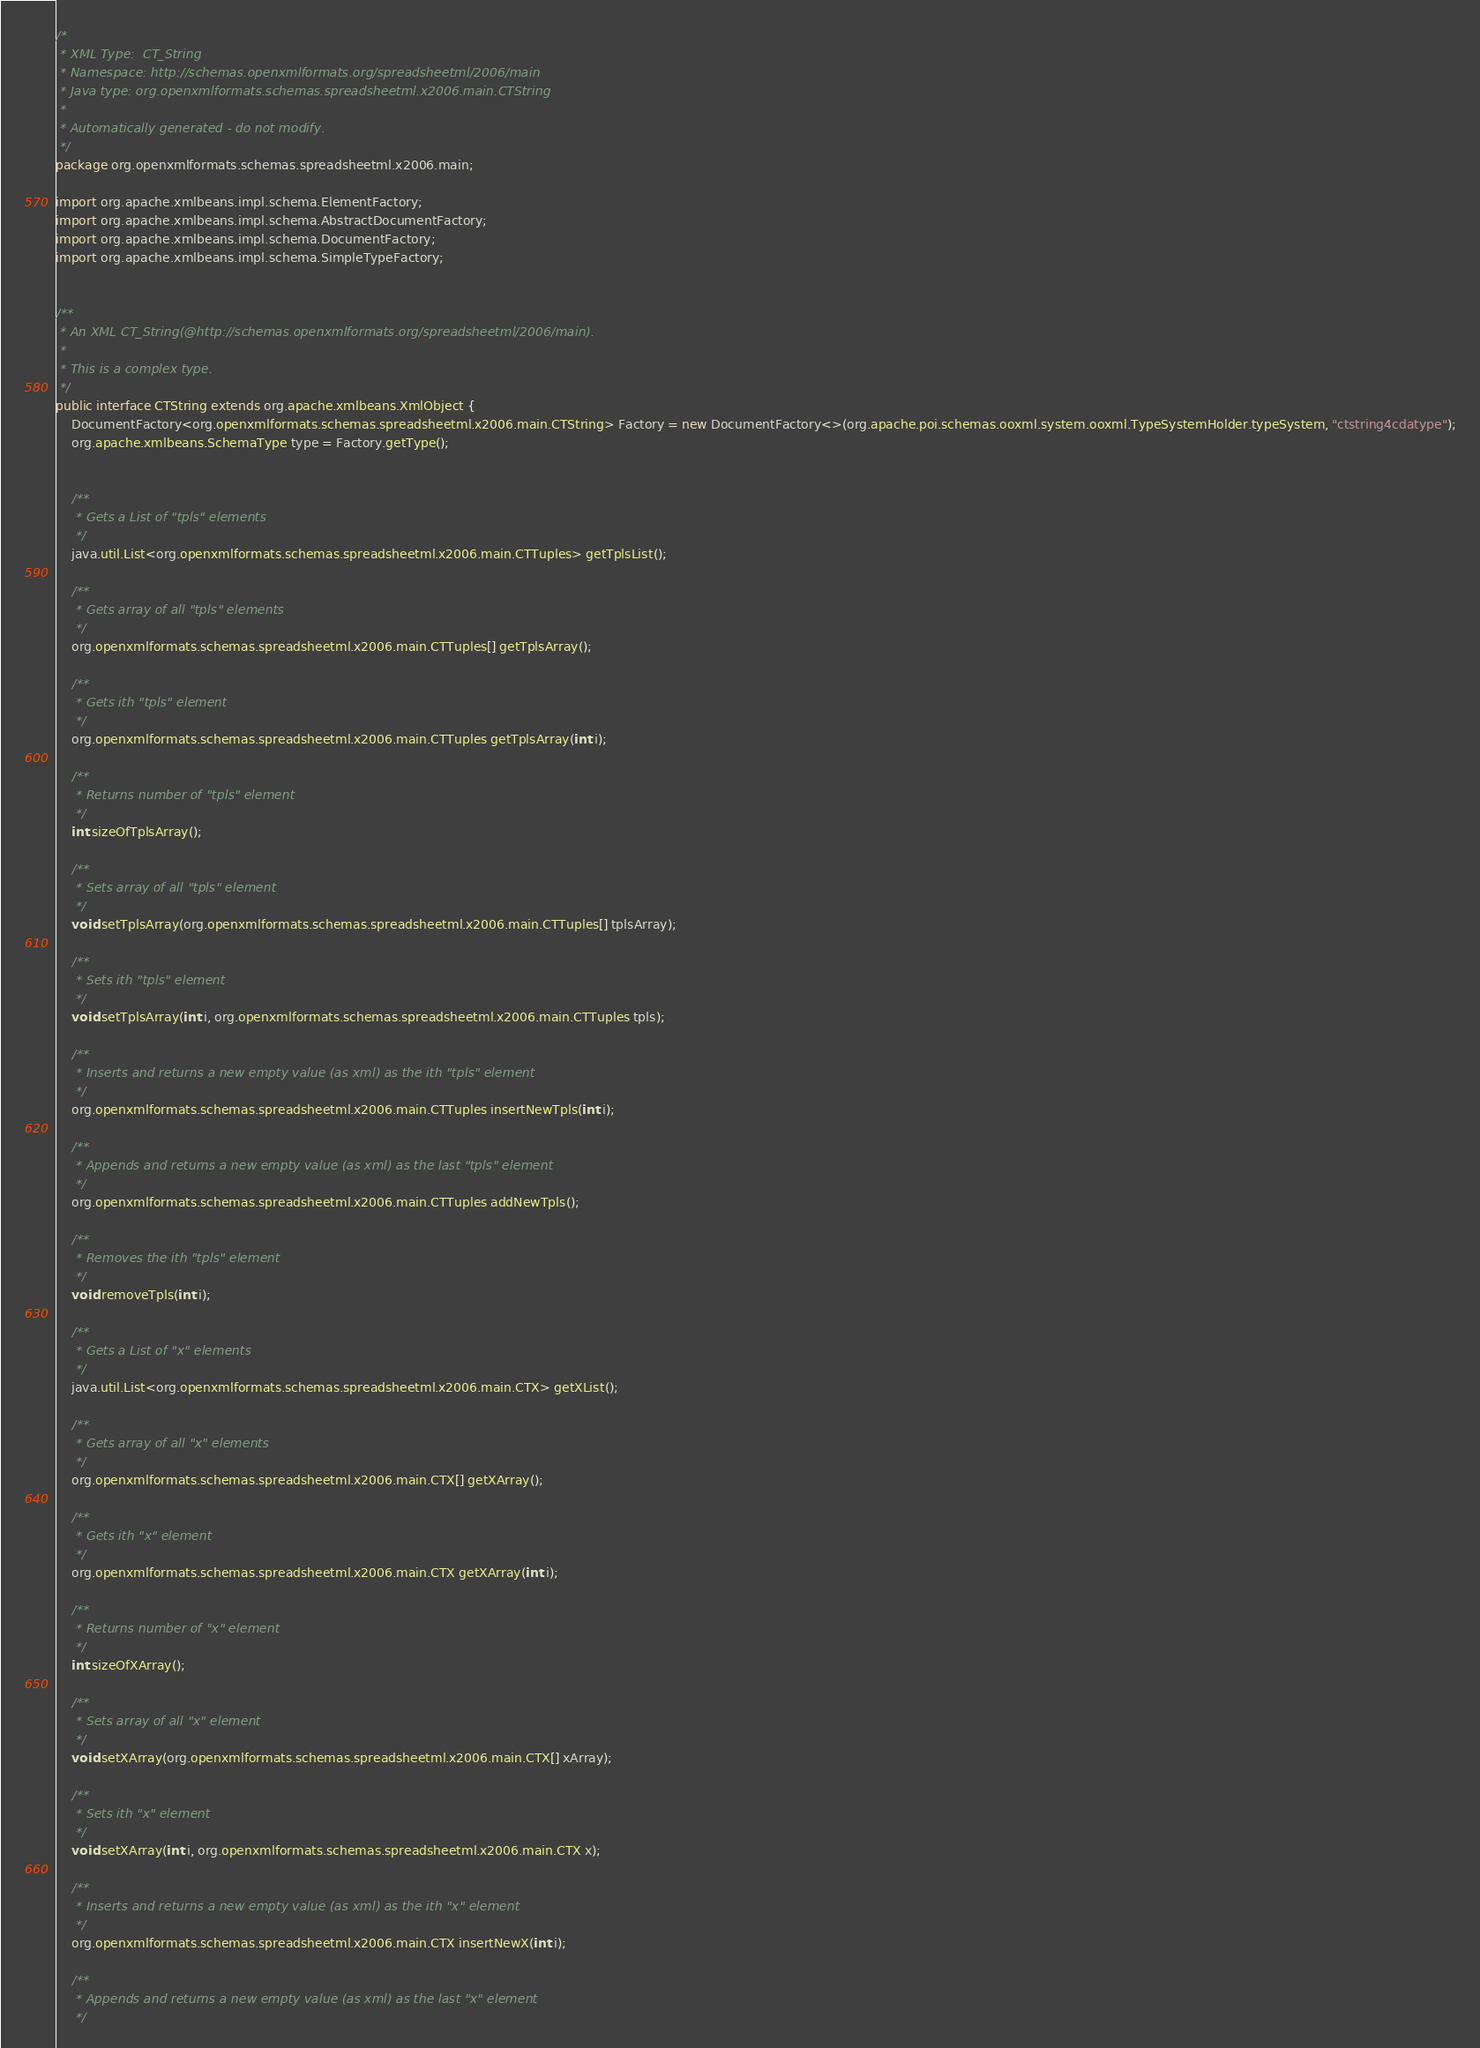Convert code to text. <code><loc_0><loc_0><loc_500><loc_500><_Java_>/*
 * XML Type:  CT_String
 * Namespace: http://schemas.openxmlformats.org/spreadsheetml/2006/main
 * Java type: org.openxmlformats.schemas.spreadsheetml.x2006.main.CTString
 *
 * Automatically generated - do not modify.
 */
package org.openxmlformats.schemas.spreadsheetml.x2006.main;

import org.apache.xmlbeans.impl.schema.ElementFactory;
import org.apache.xmlbeans.impl.schema.AbstractDocumentFactory;
import org.apache.xmlbeans.impl.schema.DocumentFactory;
import org.apache.xmlbeans.impl.schema.SimpleTypeFactory;


/**
 * An XML CT_String(@http://schemas.openxmlformats.org/spreadsheetml/2006/main).
 *
 * This is a complex type.
 */
public interface CTString extends org.apache.xmlbeans.XmlObject {
    DocumentFactory<org.openxmlformats.schemas.spreadsheetml.x2006.main.CTString> Factory = new DocumentFactory<>(org.apache.poi.schemas.ooxml.system.ooxml.TypeSystemHolder.typeSystem, "ctstring4cdatype");
    org.apache.xmlbeans.SchemaType type = Factory.getType();


    /**
     * Gets a List of "tpls" elements
     */
    java.util.List<org.openxmlformats.schemas.spreadsheetml.x2006.main.CTTuples> getTplsList();

    /**
     * Gets array of all "tpls" elements
     */
    org.openxmlformats.schemas.spreadsheetml.x2006.main.CTTuples[] getTplsArray();

    /**
     * Gets ith "tpls" element
     */
    org.openxmlformats.schemas.spreadsheetml.x2006.main.CTTuples getTplsArray(int i);

    /**
     * Returns number of "tpls" element
     */
    int sizeOfTplsArray();

    /**
     * Sets array of all "tpls" element
     */
    void setTplsArray(org.openxmlformats.schemas.spreadsheetml.x2006.main.CTTuples[] tplsArray);

    /**
     * Sets ith "tpls" element
     */
    void setTplsArray(int i, org.openxmlformats.schemas.spreadsheetml.x2006.main.CTTuples tpls);

    /**
     * Inserts and returns a new empty value (as xml) as the ith "tpls" element
     */
    org.openxmlformats.schemas.spreadsheetml.x2006.main.CTTuples insertNewTpls(int i);

    /**
     * Appends and returns a new empty value (as xml) as the last "tpls" element
     */
    org.openxmlformats.schemas.spreadsheetml.x2006.main.CTTuples addNewTpls();

    /**
     * Removes the ith "tpls" element
     */
    void removeTpls(int i);

    /**
     * Gets a List of "x" elements
     */
    java.util.List<org.openxmlformats.schemas.spreadsheetml.x2006.main.CTX> getXList();

    /**
     * Gets array of all "x" elements
     */
    org.openxmlformats.schemas.spreadsheetml.x2006.main.CTX[] getXArray();

    /**
     * Gets ith "x" element
     */
    org.openxmlformats.schemas.spreadsheetml.x2006.main.CTX getXArray(int i);

    /**
     * Returns number of "x" element
     */
    int sizeOfXArray();

    /**
     * Sets array of all "x" element
     */
    void setXArray(org.openxmlformats.schemas.spreadsheetml.x2006.main.CTX[] xArray);

    /**
     * Sets ith "x" element
     */
    void setXArray(int i, org.openxmlformats.schemas.spreadsheetml.x2006.main.CTX x);

    /**
     * Inserts and returns a new empty value (as xml) as the ith "x" element
     */
    org.openxmlformats.schemas.spreadsheetml.x2006.main.CTX insertNewX(int i);

    /**
     * Appends and returns a new empty value (as xml) as the last "x" element
     */</code> 